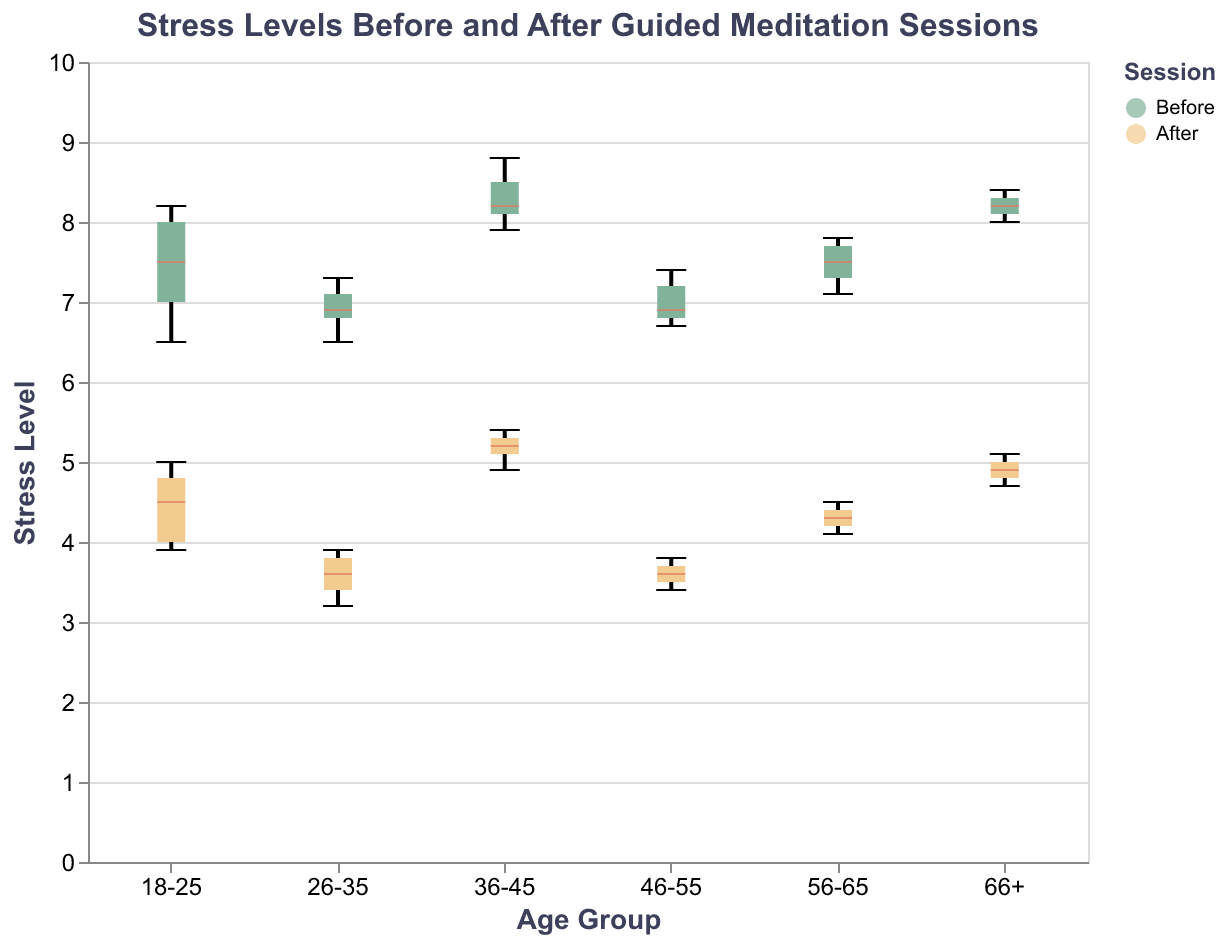What is the title of the figure? The title of the figure is typically displayed at the top and is a text element that summarizes the content of the chart.
Answer: Stress Levels Before and After Guided Meditation Sessions What age group has the highest median stress level before the guided meditation session? To find the highest median stress level before the session, look for the median lines (marked differently, e.g., in a different color) in the "Before" box plots across all age groups.
Answer: 36-45 What is the median stress level of the 26-35 age group after the guided meditation session? Identify the median line in the box plot for the "After" session in the 26-35 age group. It’s the horizontal line within the box.
Answer: 3.6 Which age group shows the largest reduction in median stress levels due to the guided meditation sessions? Calculate the difference in the median stress levels between the "Before" and "After" sessions for each age group. The largest difference indicates the age group with the largest reduction.
Answer: 26-35 What is the interquartile range (IQR) of the stress levels for the 18-25 age group before the guided meditation session? The interquartile range is the range between the first quartile (Q1) and the third quartile (Q3). In the 18-25 age group "Before" session, identify Q1 and Q3 from the box plot and subtract Q1 from Q3.
Answer: 1.2 (from approx 7.0 to 8.2) Which age group has the smallest spread (range) of stress levels before the guided meditation session? The spread (range) is the difference between the minimum and maximum values. Observe the whiskers of the "Before" box plots for each age group and find the one with the shortest whiskers.
Answer: 46-55 How does the median stress level compare between the 56-65 and 66+ age groups after the guided meditation sessions? Compare the horizontal median lines within the "After" box plots for the 56-65 and 66+ age groups.
Answer: The median stress level of the 66+ group is slightly higher than that of the 56-65 group Which session (Before or After) for the 36-45 age group has a lower maximum stress level? Inspect the whiskers of the box plot for the 36-45 age group for both sessions. The "maximum" value is represented by the top whisker’s endpoint. Compare these endpoints.
Answer: After Is there any age group that shows an overlap in the stress levels between the "Before" and "After" sessions? Look for overlaps in the box plots (the boxes and whiskers) between "Before" and "After" sessions for each age group. If the ranges (represented by the boxes and whiskers) overlap, stress levels overlap.
Answer: Yes, 66+ How does the median stress level change from "Before" to "After" for the 18-25 age group? Observe the median lines within the box plots for the 18-25 age group and calculate the difference between the "Before" and "After" sessions.
Answer: Decreases by approximately 3.0 units 